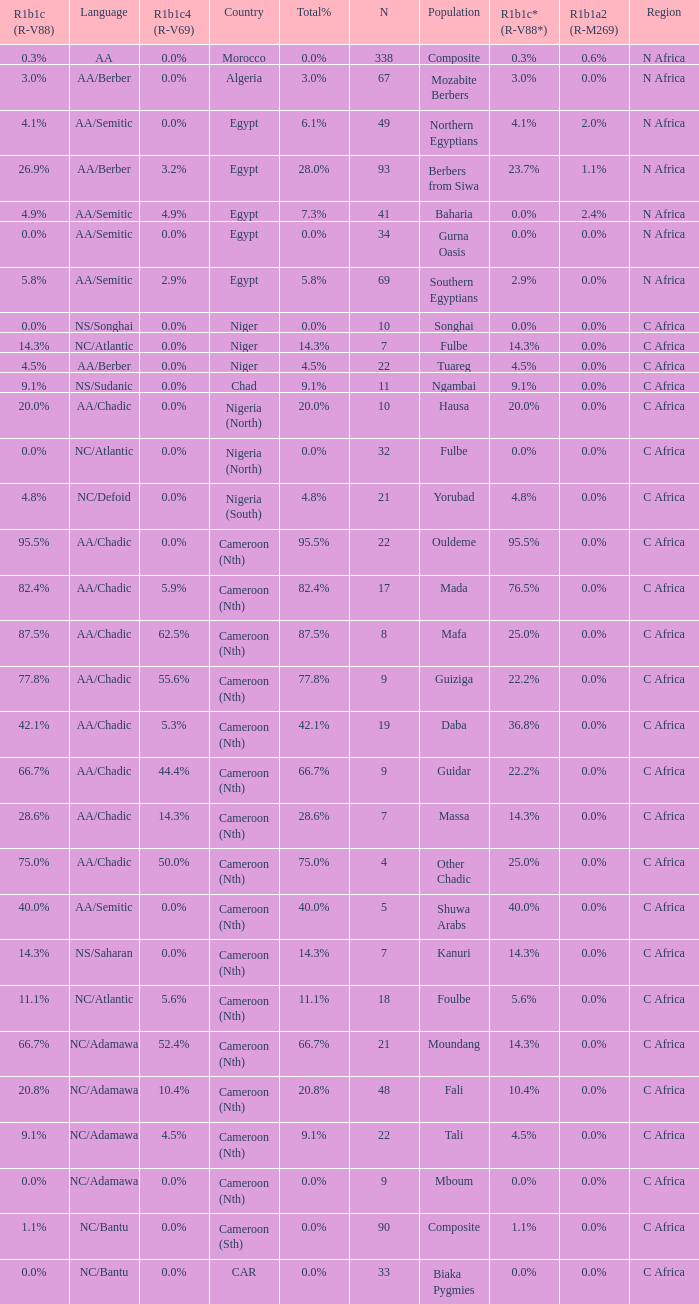Can you parse all the data within this table? {'header': ['R1b1c (R-V88)', 'Language', 'R1b1c4 (R-V69)', 'Country', 'Total%', 'N', 'Population', 'R1b1c* (R-V88*)', 'R1b1a2 (R-M269)', 'Region'], 'rows': [['0.3%', 'AA', '0.0%', 'Morocco', '0.0%', '338', 'Composite', '0.3%', '0.6%', 'N Africa'], ['3.0%', 'AA/Berber', '0.0%', 'Algeria', '3.0%', '67', 'Mozabite Berbers', '3.0%', '0.0%', 'N Africa'], ['4.1%', 'AA/Semitic', '0.0%', 'Egypt', '6.1%', '49', 'Northern Egyptians', '4.1%', '2.0%', 'N Africa'], ['26.9%', 'AA/Berber', '3.2%', 'Egypt', '28.0%', '93', 'Berbers from Siwa', '23.7%', '1.1%', 'N Africa'], ['4.9%', 'AA/Semitic', '4.9%', 'Egypt', '7.3%', '41', 'Baharia', '0.0%', '2.4%', 'N Africa'], ['0.0%', 'AA/Semitic', '0.0%', 'Egypt', '0.0%', '34', 'Gurna Oasis', '0.0%', '0.0%', 'N Africa'], ['5.8%', 'AA/Semitic', '2.9%', 'Egypt', '5.8%', '69', 'Southern Egyptians', '2.9%', '0.0%', 'N Africa'], ['0.0%', 'NS/Songhai', '0.0%', 'Niger', '0.0%', '10', 'Songhai', '0.0%', '0.0%', 'C Africa'], ['14.3%', 'NC/Atlantic', '0.0%', 'Niger', '14.3%', '7', 'Fulbe', '14.3%', '0.0%', 'C Africa'], ['4.5%', 'AA/Berber', '0.0%', 'Niger', '4.5%', '22', 'Tuareg', '4.5%', '0.0%', 'C Africa'], ['9.1%', 'NS/Sudanic', '0.0%', 'Chad', '9.1%', '11', 'Ngambai', '9.1%', '0.0%', 'C Africa'], ['20.0%', 'AA/Chadic', '0.0%', 'Nigeria (North)', '20.0%', '10', 'Hausa', '20.0%', '0.0%', 'C Africa'], ['0.0%', 'NC/Atlantic', '0.0%', 'Nigeria (North)', '0.0%', '32', 'Fulbe', '0.0%', '0.0%', 'C Africa'], ['4.8%', 'NC/Defoid', '0.0%', 'Nigeria (South)', '4.8%', '21', 'Yorubad', '4.8%', '0.0%', 'C Africa'], ['95.5%', 'AA/Chadic', '0.0%', 'Cameroon (Nth)', '95.5%', '22', 'Ouldeme', '95.5%', '0.0%', 'C Africa'], ['82.4%', 'AA/Chadic', '5.9%', 'Cameroon (Nth)', '82.4%', '17', 'Mada', '76.5%', '0.0%', 'C Africa'], ['87.5%', 'AA/Chadic', '62.5%', 'Cameroon (Nth)', '87.5%', '8', 'Mafa', '25.0%', '0.0%', 'C Africa'], ['77.8%', 'AA/Chadic', '55.6%', 'Cameroon (Nth)', '77.8%', '9', 'Guiziga', '22.2%', '0.0%', 'C Africa'], ['42.1%', 'AA/Chadic', '5.3%', 'Cameroon (Nth)', '42.1%', '19', 'Daba', '36.8%', '0.0%', 'C Africa'], ['66.7%', 'AA/Chadic', '44.4%', 'Cameroon (Nth)', '66.7%', '9', 'Guidar', '22.2%', '0.0%', 'C Africa'], ['28.6%', 'AA/Chadic', '14.3%', 'Cameroon (Nth)', '28.6%', '7', 'Massa', '14.3%', '0.0%', 'C Africa'], ['75.0%', 'AA/Chadic', '50.0%', 'Cameroon (Nth)', '75.0%', '4', 'Other Chadic', '25.0%', '0.0%', 'C Africa'], ['40.0%', 'AA/Semitic', '0.0%', 'Cameroon (Nth)', '40.0%', '5', 'Shuwa Arabs', '40.0%', '0.0%', 'C Africa'], ['14.3%', 'NS/Saharan', '0.0%', 'Cameroon (Nth)', '14.3%', '7', 'Kanuri', '14.3%', '0.0%', 'C Africa'], ['11.1%', 'NC/Atlantic', '5.6%', 'Cameroon (Nth)', '11.1%', '18', 'Foulbe', '5.6%', '0.0%', 'C Africa'], ['66.7%', 'NC/Adamawa', '52.4%', 'Cameroon (Nth)', '66.7%', '21', 'Moundang', '14.3%', '0.0%', 'C Africa'], ['20.8%', 'NC/Adamawa', '10.4%', 'Cameroon (Nth)', '20.8%', '48', 'Fali', '10.4%', '0.0%', 'C Africa'], ['9.1%', 'NC/Adamawa', '4.5%', 'Cameroon (Nth)', '9.1%', '22', 'Tali', '4.5%', '0.0%', 'C Africa'], ['0.0%', 'NC/Adamawa', '0.0%', 'Cameroon (Nth)', '0.0%', '9', 'Mboum', '0.0%', '0.0%', 'C Africa'], ['1.1%', 'NC/Bantu', '0.0%', 'Cameroon (Sth)', '0.0%', '90', 'Composite', '1.1%', '0.0%', 'C Africa'], ['0.0%', 'NC/Bantu', '0.0%', 'CAR', '0.0%', '33', 'Biaka Pygmies', '0.0%', '0.0%', 'C Africa']]} How many n are listed for 0.6% r1b1a2 (r-m269)? 1.0. 